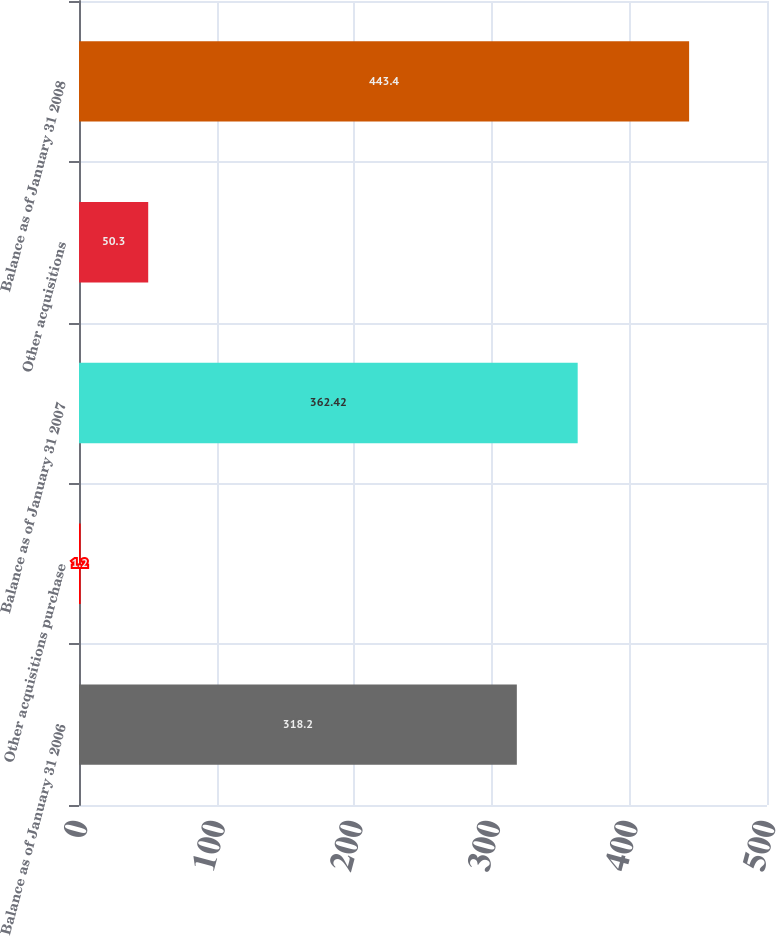Convert chart to OTSL. <chart><loc_0><loc_0><loc_500><loc_500><bar_chart><fcel>Balance as of January 31 2006<fcel>Other acquisitions purchase<fcel>Balance as of January 31 2007<fcel>Other acquisitions<fcel>Balance as of January 31 2008<nl><fcel>318.2<fcel>1.2<fcel>362.42<fcel>50.3<fcel>443.4<nl></chart> 